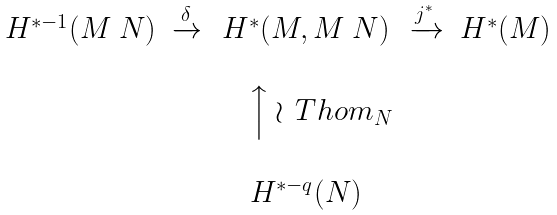Convert formula to latex. <formula><loc_0><loc_0><loc_500><loc_500>\begin{matrix} H ^ { * - 1 } ( M \ N ) & \xrightarrow { \delta } & H ^ { * } ( M , M \ N ) & \xrightarrow { j ^ { * } } & H ^ { * } ( M ) \\ \\ & & \quad \Big \uparrow \wr \, T h o m _ { N } & & \\ \\ & & H ^ { * - q } ( N ) & & \end{matrix}</formula> 